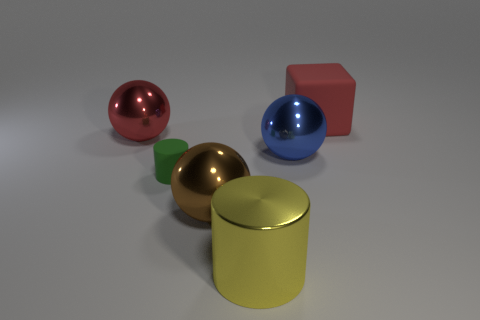Is there anything else that is made of the same material as the big brown sphere?
Your answer should be very brief. Yes. There is a sphere that is the same color as the big matte block; what is its size?
Give a very brief answer. Large. There is a sphere that is both to the left of the blue metallic thing and to the right of the green object; what color is it?
Your response must be concise. Brown. What is the color of the rubber object in front of the large object behind the red object on the left side of the large rubber cube?
Provide a short and direct response. Green. There is a rubber block that is the same size as the brown metallic ball; what is its color?
Ensure brevity in your answer.  Red. There is a large object that is behind the large red object that is on the left side of the large object that is behind the big red metallic ball; what shape is it?
Provide a succinct answer. Cube. There is a big thing that is the same color as the large cube; what is its shape?
Keep it short and to the point. Sphere. What number of things are either large yellow rubber cylinders or big red matte objects to the right of the big red sphere?
Make the answer very short. 1. Is the size of the cylinder that is behind the metal cylinder the same as the large brown shiny sphere?
Provide a short and direct response. No. What material is the red thing on the left side of the blue sphere?
Keep it short and to the point. Metal. 